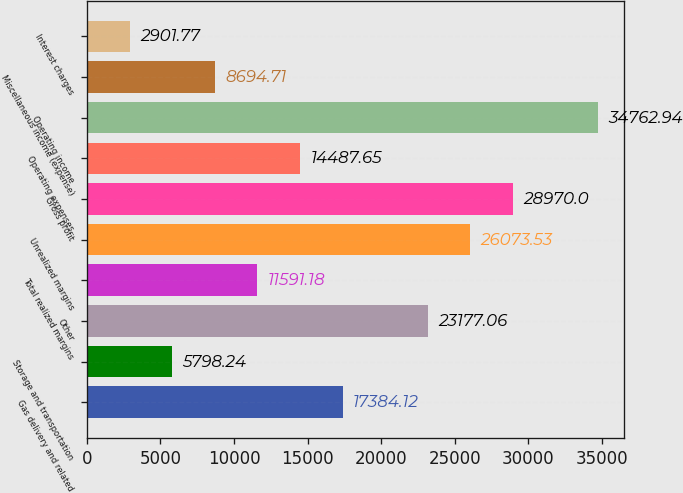Convert chart. <chart><loc_0><loc_0><loc_500><loc_500><bar_chart><fcel>Gas delivery and related<fcel>Storage and transportation<fcel>Other<fcel>Total realized margins<fcel>Unrealized margins<fcel>Gross profit<fcel>Operating expenses<fcel>Operating income<fcel>Miscellaneous income (expense)<fcel>Interest charges<nl><fcel>17384.1<fcel>5798.24<fcel>23177.1<fcel>11591.2<fcel>26073.5<fcel>28970<fcel>14487.6<fcel>34762.9<fcel>8694.71<fcel>2901.77<nl></chart> 